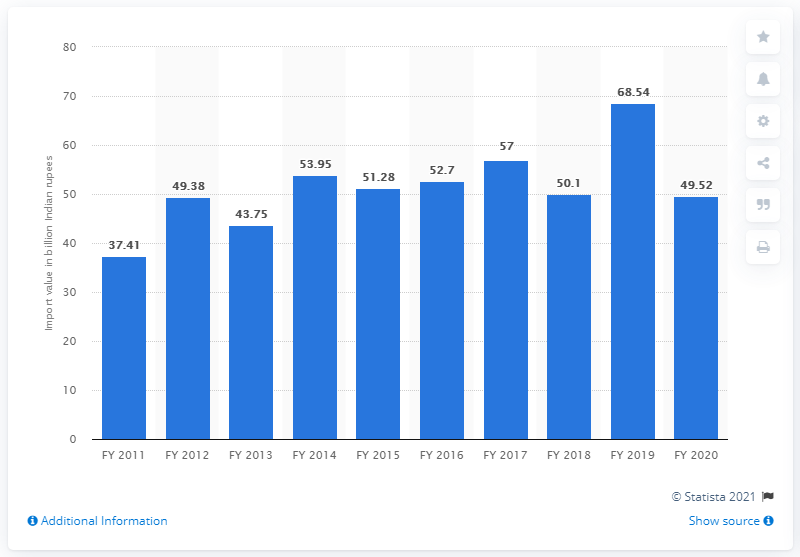Outline some significant characteristics in this image. During fiscal year 2020, India imported a total of 49.38 million Indian rupees worth of newsprint. 